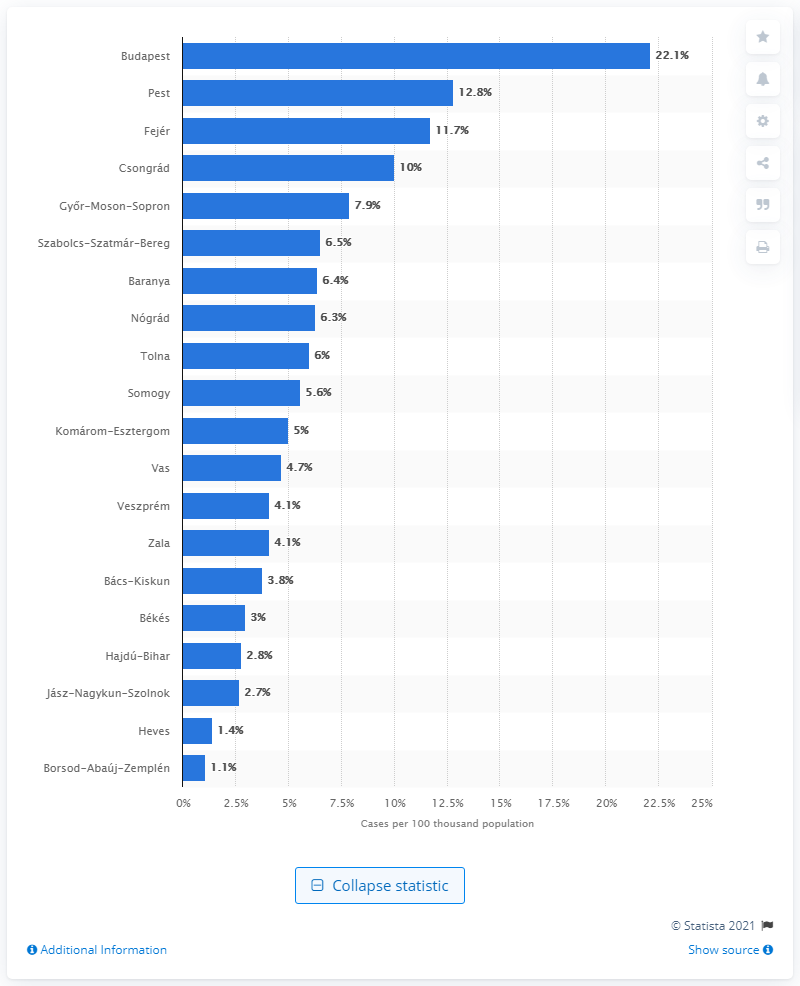Give some essential details in this illustration. As of April 8, 2020, the city with the highest number of coronavirus infected people per 100 thousand inhabitants was Budapest. 